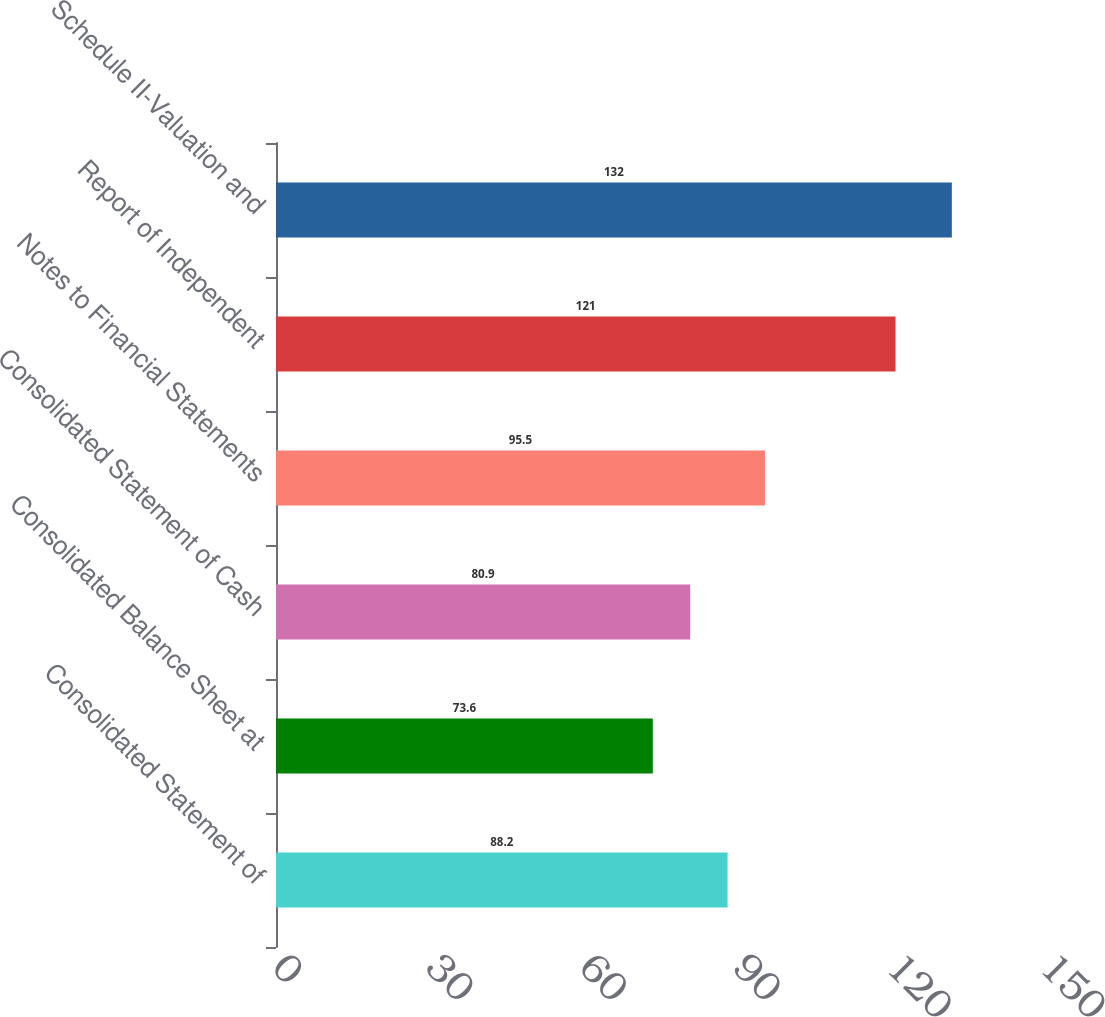Convert chart to OTSL. <chart><loc_0><loc_0><loc_500><loc_500><bar_chart><fcel>Consolidated Statement of<fcel>Consolidated Balance Sheet at<fcel>Consolidated Statement of Cash<fcel>Notes to Financial Statements<fcel>Report of Independent<fcel>Schedule II-Valuation and<nl><fcel>88.2<fcel>73.6<fcel>80.9<fcel>95.5<fcel>121<fcel>132<nl></chart> 